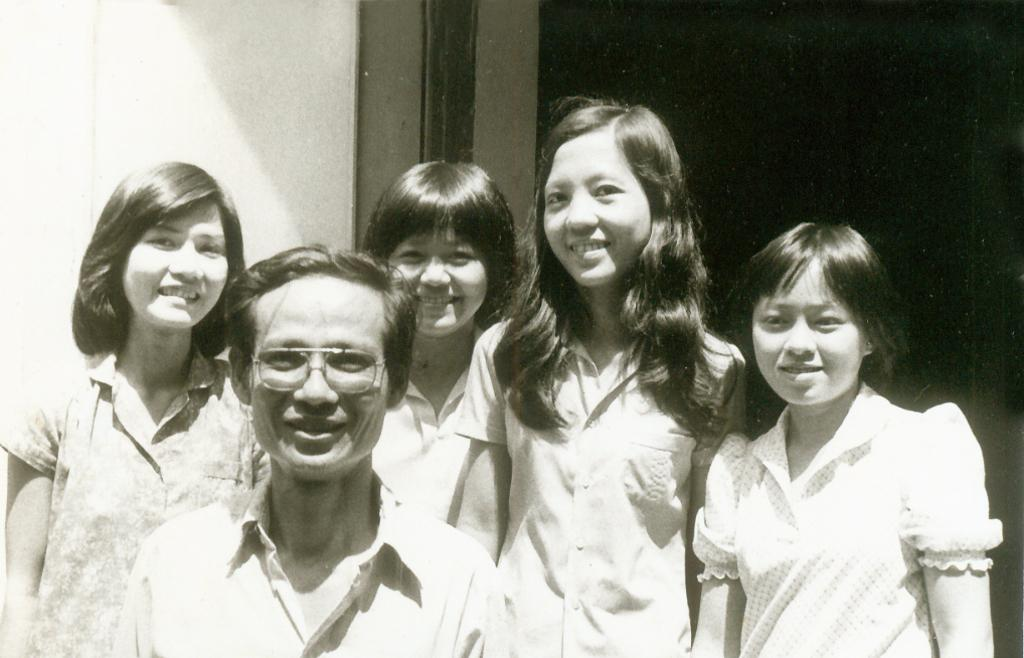What is the color scheme of the image? The image is black and white. What can be seen in the image? There is a group of people in the image. How are the people positioned in the image? The people are standing. What expressions do the people have in the image? The people are smiling. What is visible in the background of the image? There is a wall in the background of the image. Can you see a flock of birds flying over the people in the image? There is no flock of birds visible in the image; it only features a group of people standing and smiling. 